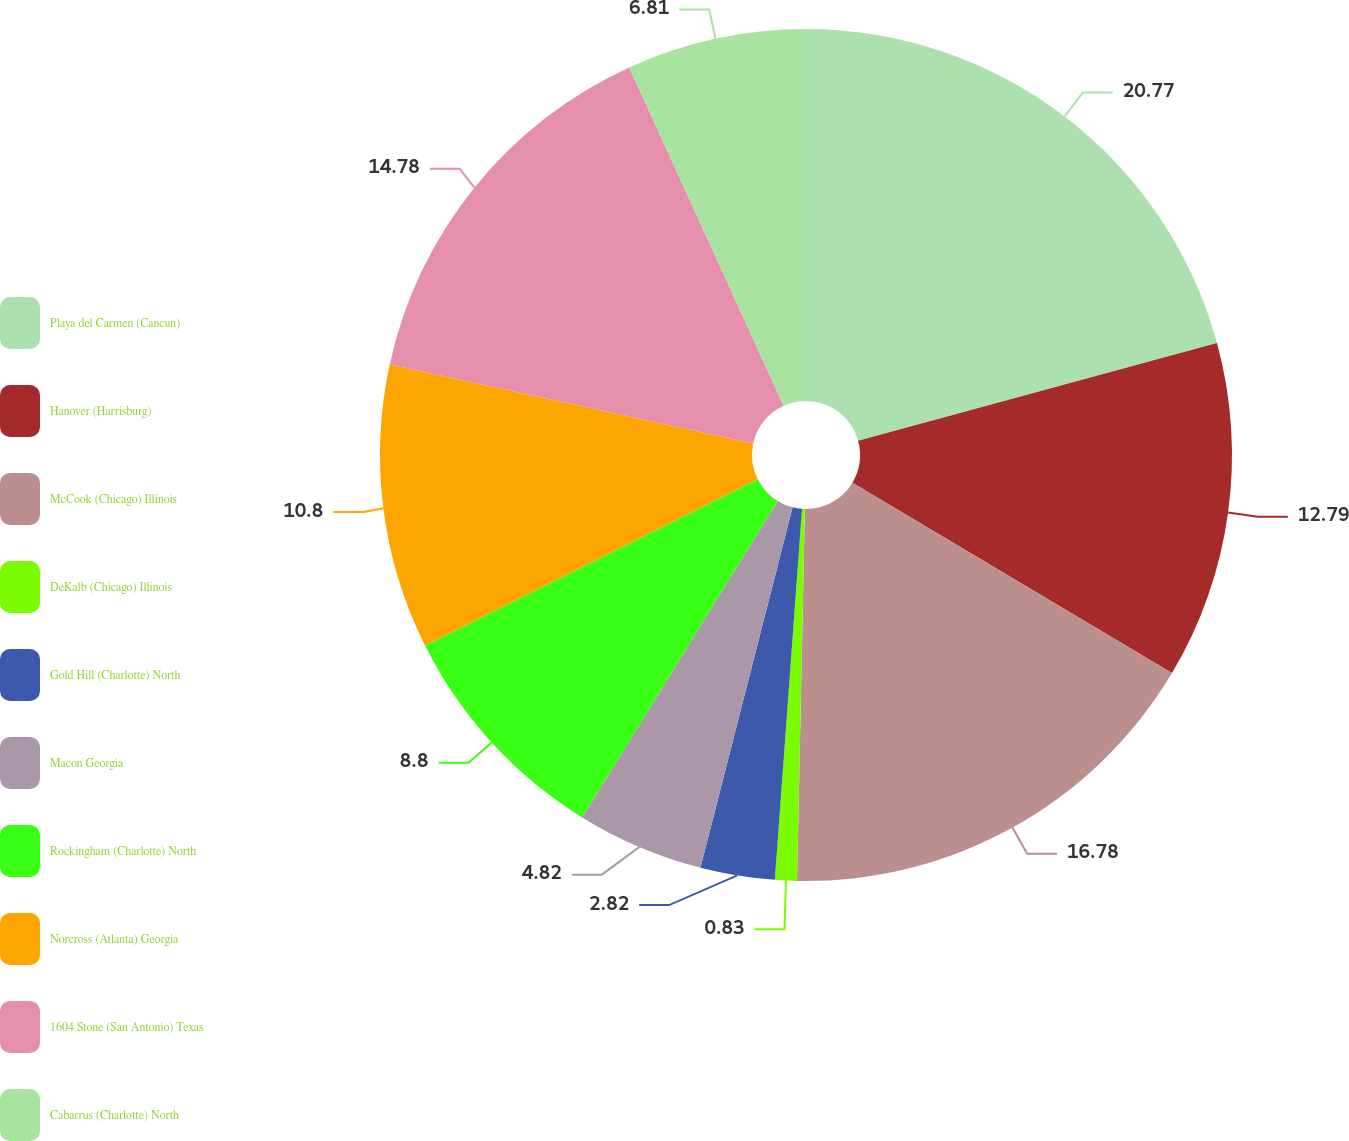Convert chart. <chart><loc_0><loc_0><loc_500><loc_500><pie_chart><fcel>Playa del Carmen (Cancun)<fcel>Hanover (Harrisburg)<fcel>McCook (Chicago) Illinois<fcel>DeKalb (Chicago) Illinois<fcel>Gold Hill (Charlotte) North<fcel>Macon Georgia<fcel>Rockingham (Charlotte) North<fcel>Norcross (Atlanta) Georgia<fcel>1604 Stone (San Antonio) Texas<fcel>Cabarrus (Charlotte) North<nl><fcel>20.76%<fcel>12.79%<fcel>16.78%<fcel>0.83%<fcel>2.82%<fcel>4.82%<fcel>8.8%<fcel>10.8%<fcel>14.78%<fcel>6.81%<nl></chart> 